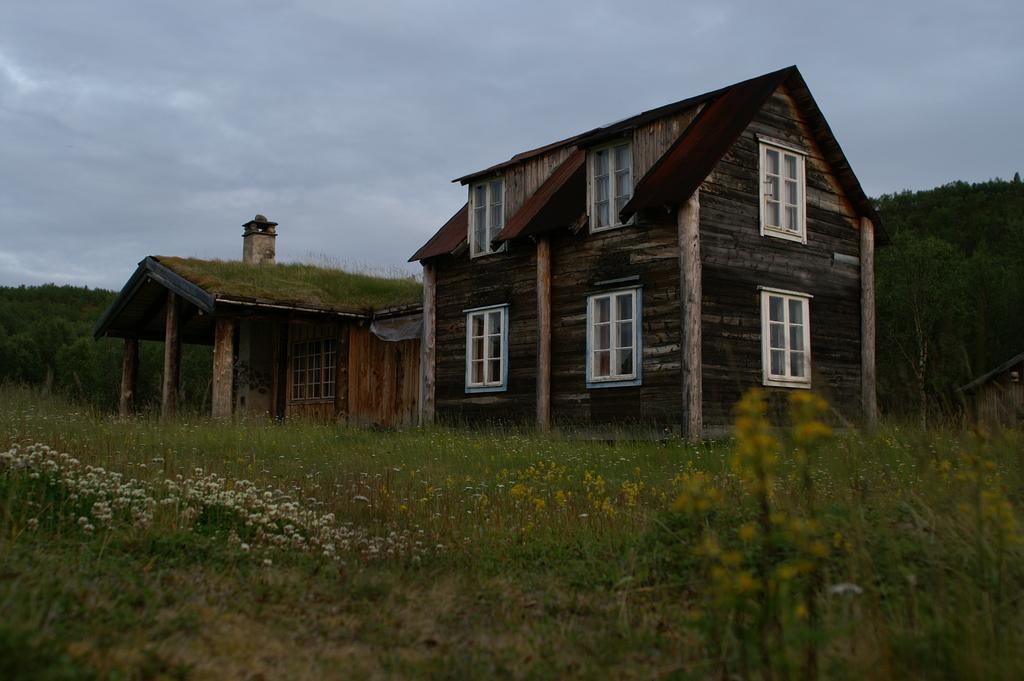In one or two sentences, can you explain what this image depicts? In this image we can see there are wooden houses, around the house there is a greenery with trees, plants and the sky. In the background there is the sky. 